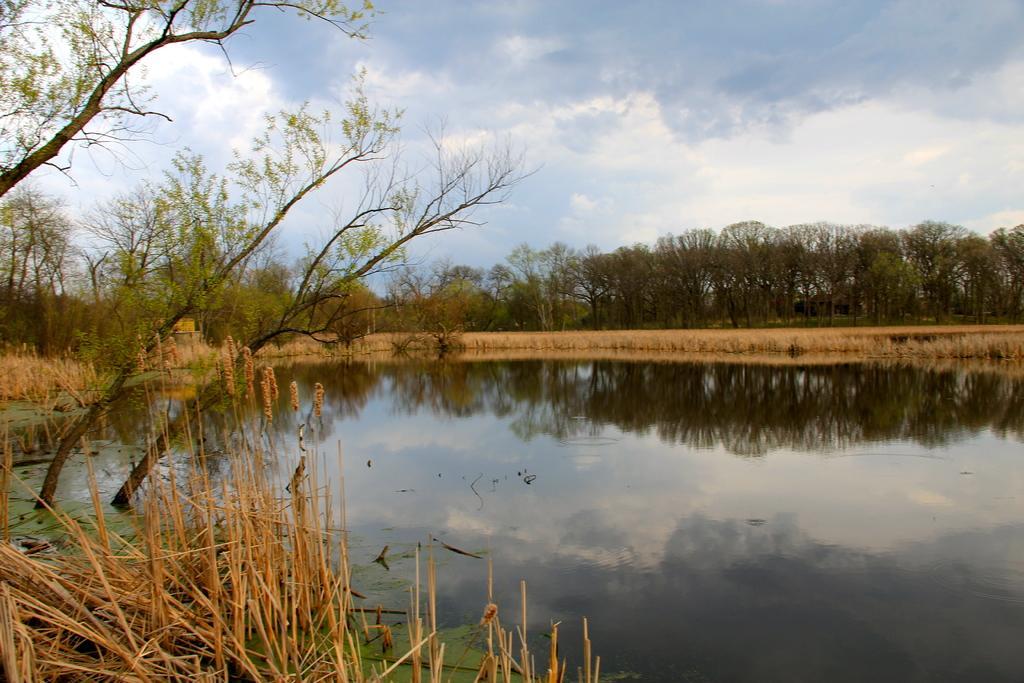Could you give a brief overview of what you see in this image? In the image we can see there are dry plants and there is water. There are lot of trees and there is clear sky on the top. 